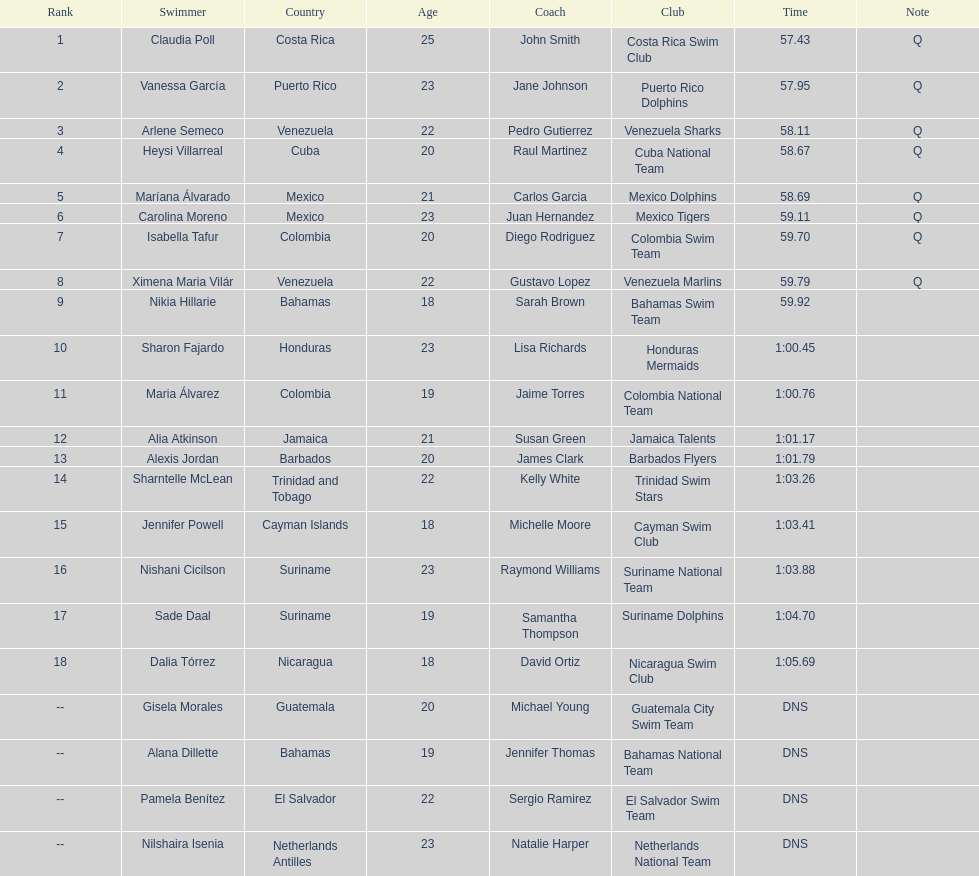How many mexican swimmers ranked in the top 10? 2. 